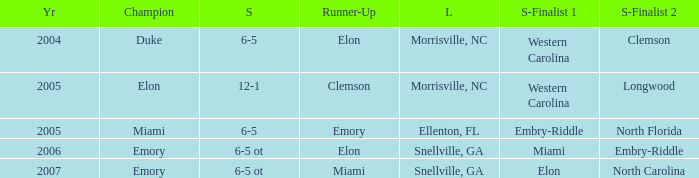How many teams were listed as runner up in 2005 and there the first semi finalist was Western Carolina? 1.0. Can you parse all the data within this table? {'header': ['Yr', 'Champion', 'S', 'Runner-Up', 'L', 'S-Finalist 1', 'S-Finalist 2'], 'rows': [['2004', 'Duke', '6-5', 'Elon', 'Morrisville, NC', 'Western Carolina', 'Clemson'], ['2005', 'Elon', '12-1', 'Clemson', 'Morrisville, NC', 'Western Carolina', 'Longwood'], ['2005', 'Miami', '6-5', 'Emory', 'Ellenton, FL', 'Embry-Riddle', 'North Florida'], ['2006', 'Emory', '6-5 ot', 'Elon', 'Snellville, GA', 'Miami', 'Embry-Riddle'], ['2007', 'Emory', '6-5 ot', 'Miami', 'Snellville, GA', 'Elon', 'North Carolina']]} 